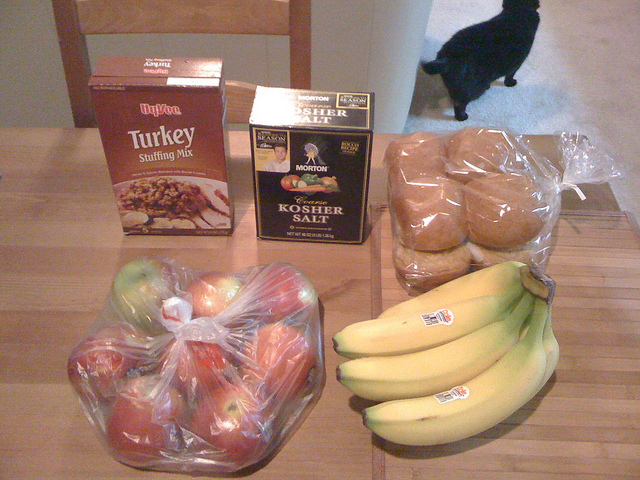Read and extract the text from this image. Turkey Stuffing Mix Stuifing Mix KOSHER SALT MORTON SALT 